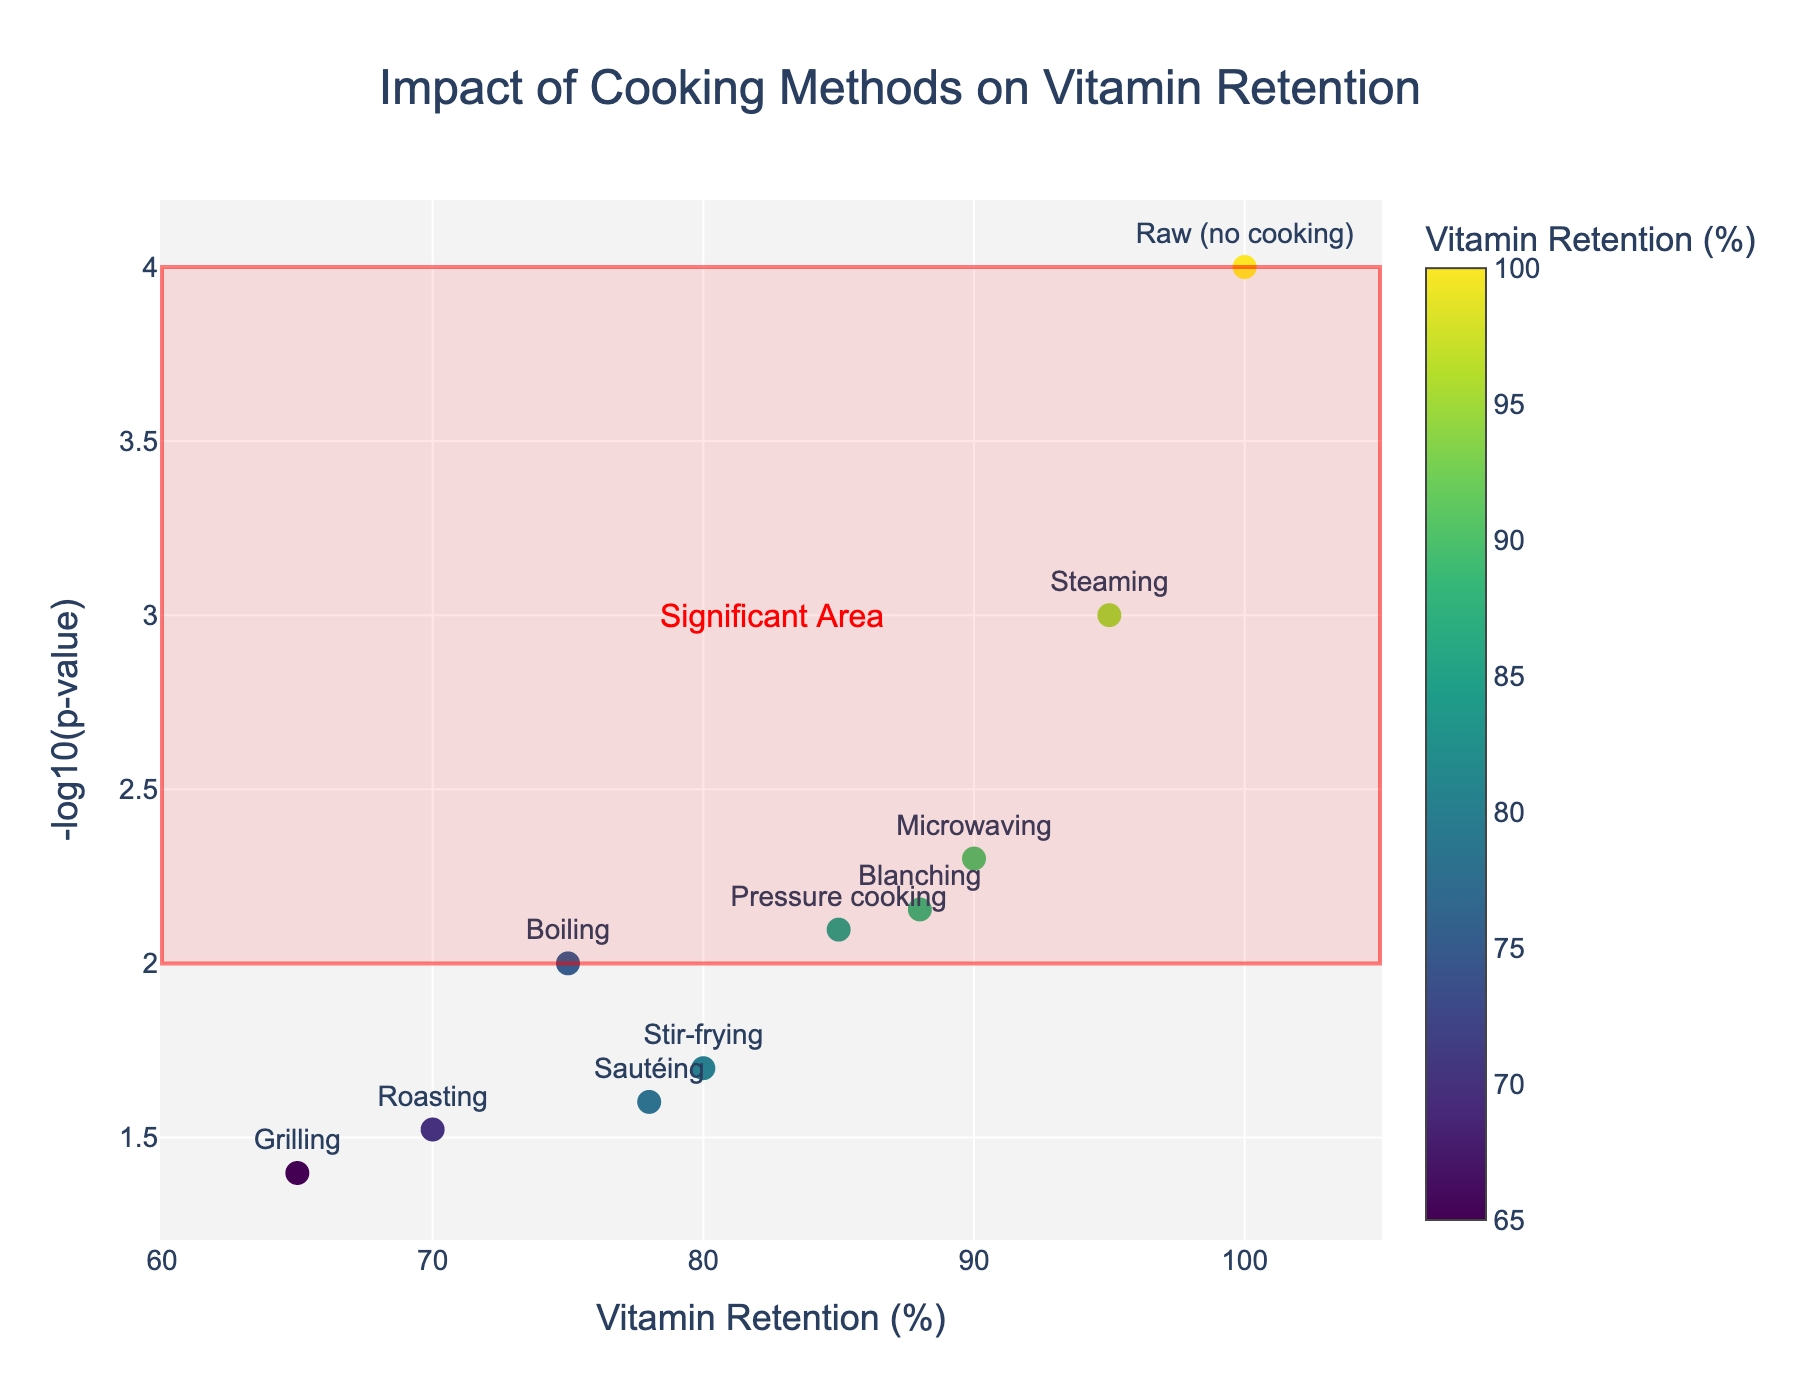What is the title of the plot? The title is typically located at the top of the plot and summarizes the main focus.
Answer: Impact of Cooking Methods on Vitamin Retention Which cooking method has the highest vitamin retention? Look for the data point that is furthest to the right on the x-axis labelled 'Vitamin Retention (%)'.
Answer: Raw (no cooking) Which cooking method has the lowest vitamin retention? Look for the data point that is furthest to the left on the x-axis labelled 'Vitamin Retention (%)'.
Answer: Grilling How many cooking methods show a vitamin retention higher than 80%? Count the number of data points that are on the right side of the 80% mark on the x-axis.
Answer: Five What does the y-axis represent in the plot? The y-axis label provides this information.
Answer: -log10(p-value) Which cooking method has the least significant p-value? Look for the data point that is at the lowest position on the y-axis.
Answer: Grilling Which cooking method has the highest -log10(p-value)? Look for the data point that is at the highest position on the y-axis.
Answer: Raw (no cooking) Compare the vitamin retention of roasting and pressure cooking. Which one retains more vitamins? Locate the data points for both cooking methods and compare their positions on the x-axis.
Answer: Pressure cooking What is the average vitamin retention percentage for boiling, roasting, and grilling? Add the vitamin retention percentages of each method and divide by the number of methods: (75 + 70 + 65) / 3.
Answer: 70 Which cooking methods fall within the "Significant Area" defined by the red rectangle? Identify data points that fall within the boundaries specified by the rectangle (60% to 105% retention and 2 to 4 -log10(p-value)).
Answer: Steaming, Microwaving, Pressure cooking, Blanching, Raw (no cooking) 